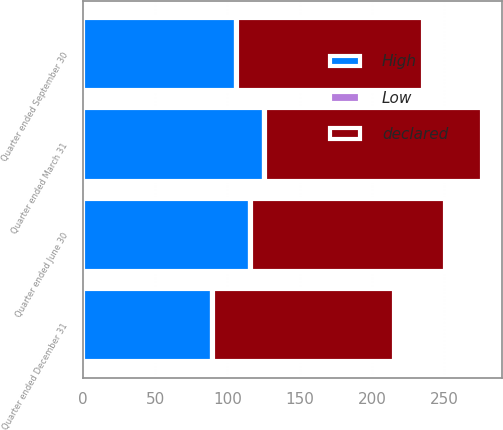<chart> <loc_0><loc_0><loc_500><loc_500><stacked_bar_chart><ecel><fcel>Quarter ended March 31<fcel>Quarter ended June 30<fcel>Quarter ended September 30<fcel>Quarter ended December 31<nl><fcel>declared<fcel>149.94<fcel>134.62<fcel>128.46<fcel>125.48<nl><fcel>High<fcel>125.3<fcel>115.38<fcel>105.91<fcel>88.97<nl><fcel>Low<fcel>0.85<fcel>0.85<fcel>0.85<fcel>0.85<nl></chart> 